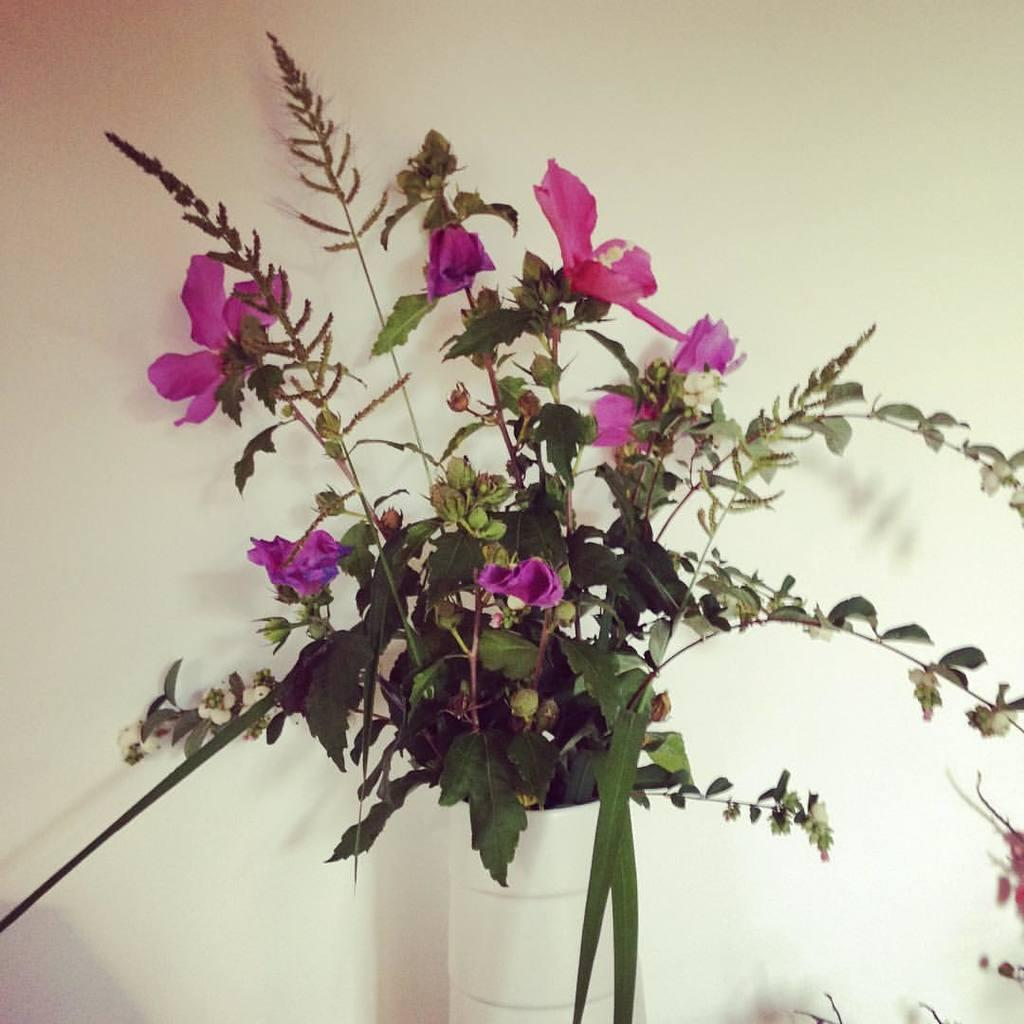What type of plants can be seen in the image? There are flowers and a house plant in the image. What is the background of the image? There is a wall visible in the image. What type of business is being conducted in the image? There is no indication of any business being conducted in the image; it primarily features plants. Can you see a zebra in the image? No, there is no zebra present in the image. 